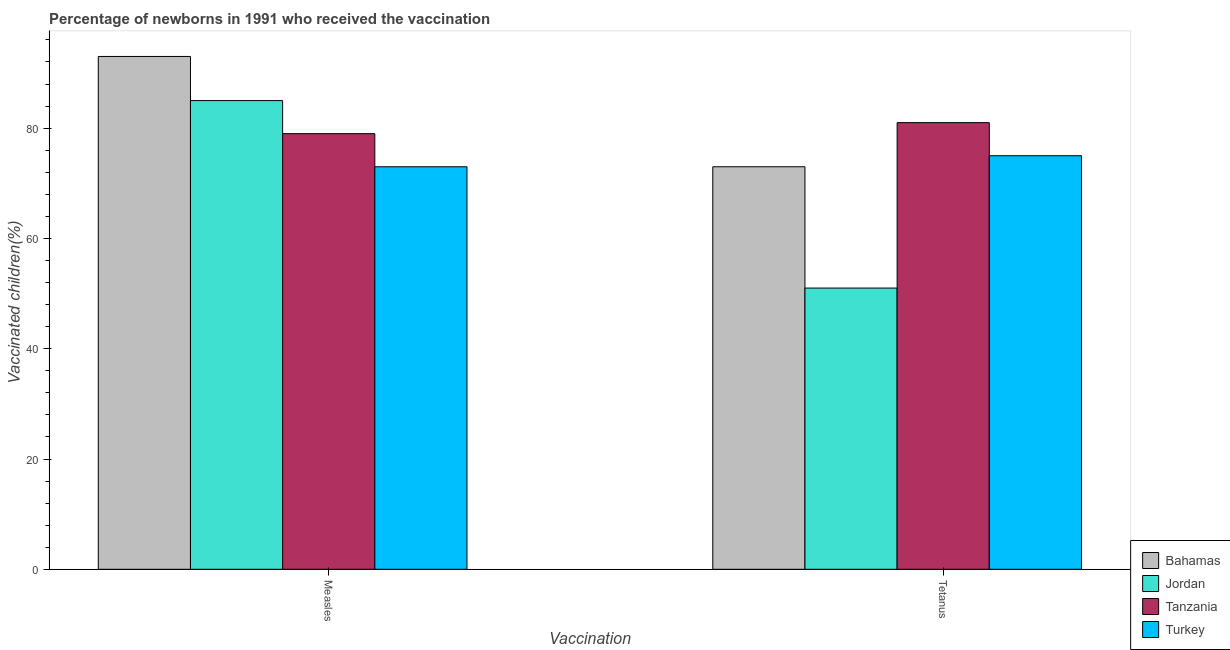Are the number of bars per tick equal to the number of legend labels?
Keep it short and to the point. Yes. Are the number of bars on each tick of the X-axis equal?
Offer a terse response. Yes. How many bars are there on the 1st tick from the right?
Make the answer very short. 4. What is the label of the 1st group of bars from the left?
Your answer should be very brief. Measles. What is the percentage of newborns who received vaccination for tetanus in Turkey?
Give a very brief answer. 75. Across all countries, what is the maximum percentage of newborns who received vaccination for tetanus?
Your answer should be compact. 81. Across all countries, what is the minimum percentage of newborns who received vaccination for tetanus?
Keep it short and to the point. 51. In which country was the percentage of newborns who received vaccination for tetanus maximum?
Offer a very short reply. Tanzania. In which country was the percentage of newborns who received vaccination for tetanus minimum?
Provide a short and direct response. Jordan. What is the total percentage of newborns who received vaccination for measles in the graph?
Make the answer very short. 330. What is the difference between the percentage of newborns who received vaccination for measles in Jordan and that in Turkey?
Make the answer very short. 12. What is the difference between the percentage of newborns who received vaccination for measles in Bahamas and the percentage of newborns who received vaccination for tetanus in Turkey?
Your response must be concise. 18. What is the difference between the percentage of newborns who received vaccination for measles and percentage of newborns who received vaccination for tetanus in Bahamas?
Make the answer very short. 20. In how many countries, is the percentage of newborns who received vaccination for tetanus greater than 76 %?
Offer a very short reply. 1. What is the ratio of the percentage of newborns who received vaccination for tetanus in Jordan to that in Bahamas?
Offer a very short reply. 0.7. Is the percentage of newborns who received vaccination for tetanus in Turkey less than that in Tanzania?
Offer a terse response. Yes. What does the 3rd bar from the left in Measles represents?
Make the answer very short. Tanzania. How many bars are there?
Offer a very short reply. 8. What is the difference between two consecutive major ticks on the Y-axis?
Offer a terse response. 20. Are the values on the major ticks of Y-axis written in scientific E-notation?
Make the answer very short. No. Does the graph contain any zero values?
Offer a terse response. No. Does the graph contain grids?
Provide a short and direct response. No. Where does the legend appear in the graph?
Keep it short and to the point. Bottom right. How many legend labels are there?
Your answer should be compact. 4. What is the title of the graph?
Your response must be concise. Percentage of newborns in 1991 who received the vaccination. What is the label or title of the X-axis?
Offer a very short reply. Vaccination. What is the label or title of the Y-axis?
Ensure brevity in your answer.  Vaccinated children(%)
. What is the Vaccinated children(%)
 of Bahamas in Measles?
Keep it short and to the point. 93. What is the Vaccinated children(%)
 in Jordan in Measles?
Your answer should be compact. 85. What is the Vaccinated children(%)
 in Tanzania in Measles?
Ensure brevity in your answer.  79. What is the Vaccinated children(%)
 in Bahamas in Tetanus?
Offer a very short reply. 73. Across all Vaccination, what is the maximum Vaccinated children(%)
 of Bahamas?
Your answer should be compact. 93. Across all Vaccination, what is the maximum Vaccinated children(%)
 in Turkey?
Your answer should be very brief. 75. Across all Vaccination, what is the minimum Vaccinated children(%)
 in Bahamas?
Offer a very short reply. 73. Across all Vaccination, what is the minimum Vaccinated children(%)
 in Tanzania?
Your response must be concise. 79. Across all Vaccination, what is the minimum Vaccinated children(%)
 in Turkey?
Your response must be concise. 73. What is the total Vaccinated children(%)
 of Bahamas in the graph?
Give a very brief answer. 166. What is the total Vaccinated children(%)
 of Jordan in the graph?
Make the answer very short. 136. What is the total Vaccinated children(%)
 in Tanzania in the graph?
Give a very brief answer. 160. What is the total Vaccinated children(%)
 in Turkey in the graph?
Ensure brevity in your answer.  148. What is the difference between the Vaccinated children(%)
 of Jordan in Measles and that in Tetanus?
Keep it short and to the point. 34. What is the difference between the Vaccinated children(%)
 in Tanzania in Measles and that in Tetanus?
Your answer should be very brief. -2. What is the difference between the Vaccinated children(%)
 in Bahamas in Measles and the Vaccinated children(%)
 in Turkey in Tetanus?
Provide a short and direct response. 18. What is the difference between the Vaccinated children(%)
 of Jordan in Measles and the Vaccinated children(%)
 of Tanzania in Tetanus?
Offer a terse response. 4. What is the difference between the Vaccinated children(%)
 in Bahamas and Vaccinated children(%)
 in Tanzania in Measles?
Your response must be concise. 14. What is the difference between the Vaccinated children(%)
 of Bahamas and Vaccinated children(%)
 of Turkey in Measles?
Make the answer very short. 20. What is the difference between the Vaccinated children(%)
 of Jordan and Vaccinated children(%)
 of Tanzania in Measles?
Your answer should be compact. 6. What is the difference between the Vaccinated children(%)
 in Tanzania and Vaccinated children(%)
 in Turkey in Measles?
Ensure brevity in your answer.  6. What is the difference between the Vaccinated children(%)
 in Bahamas and Vaccinated children(%)
 in Jordan in Tetanus?
Make the answer very short. 22. What is the difference between the Vaccinated children(%)
 of Bahamas and Vaccinated children(%)
 of Turkey in Tetanus?
Your answer should be compact. -2. What is the difference between the Vaccinated children(%)
 of Jordan and Vaccinated children(%)
 of Tanzania in Tetanus?
Provide a short and direct response. -30. What is the difference between the Vaccinated children(%)
 in Jordan and Vaccinated children(%)
 in Turkey in Tetanus?
Provide a succinct answer. -24. What is the ratio of the Vaccinated children(%)
 of Bahamas in Measles to that in Tetanus?
Give a very brief answer. 1.27. What is the ratio of the Vaccinated children(%)
 of Tanzania in Measles to that in Tetanus?
Your response must be concise. 0.98. What is the ratio of the Vaccinated children(%)
 in Turkey in Measles to that in Tetanus?
Your answer should be very brief. 0.97. What is the difference between the highest and the second highest Vaccinated children(%)
 of Jordan?
Your answer should be compact. 34. What is the difference between the highest and the second highest Vaccinated children(%)
 in Turkey?
Provide a short and direct response. 2. What is the difference between the highest and the lowest Vaccinated children(%)
 of Jordan?
Offer a terse response. 34. 